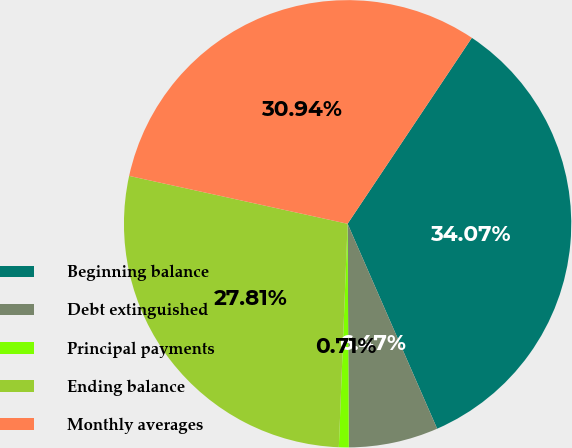Convert chart. <chart><loc_0><loc_0><loc_500><loc_500><pie_chart><fcel>Beginning balance<fcel>Debt extinguished<fcel>Principal payments<fcel>Ending balance<fcel>Monthly averages<nl><fcel>34.07%<fcel>6.47%<fcel>0.71%<fcel>27.81%<fcel>30.94%<nl></chart> 